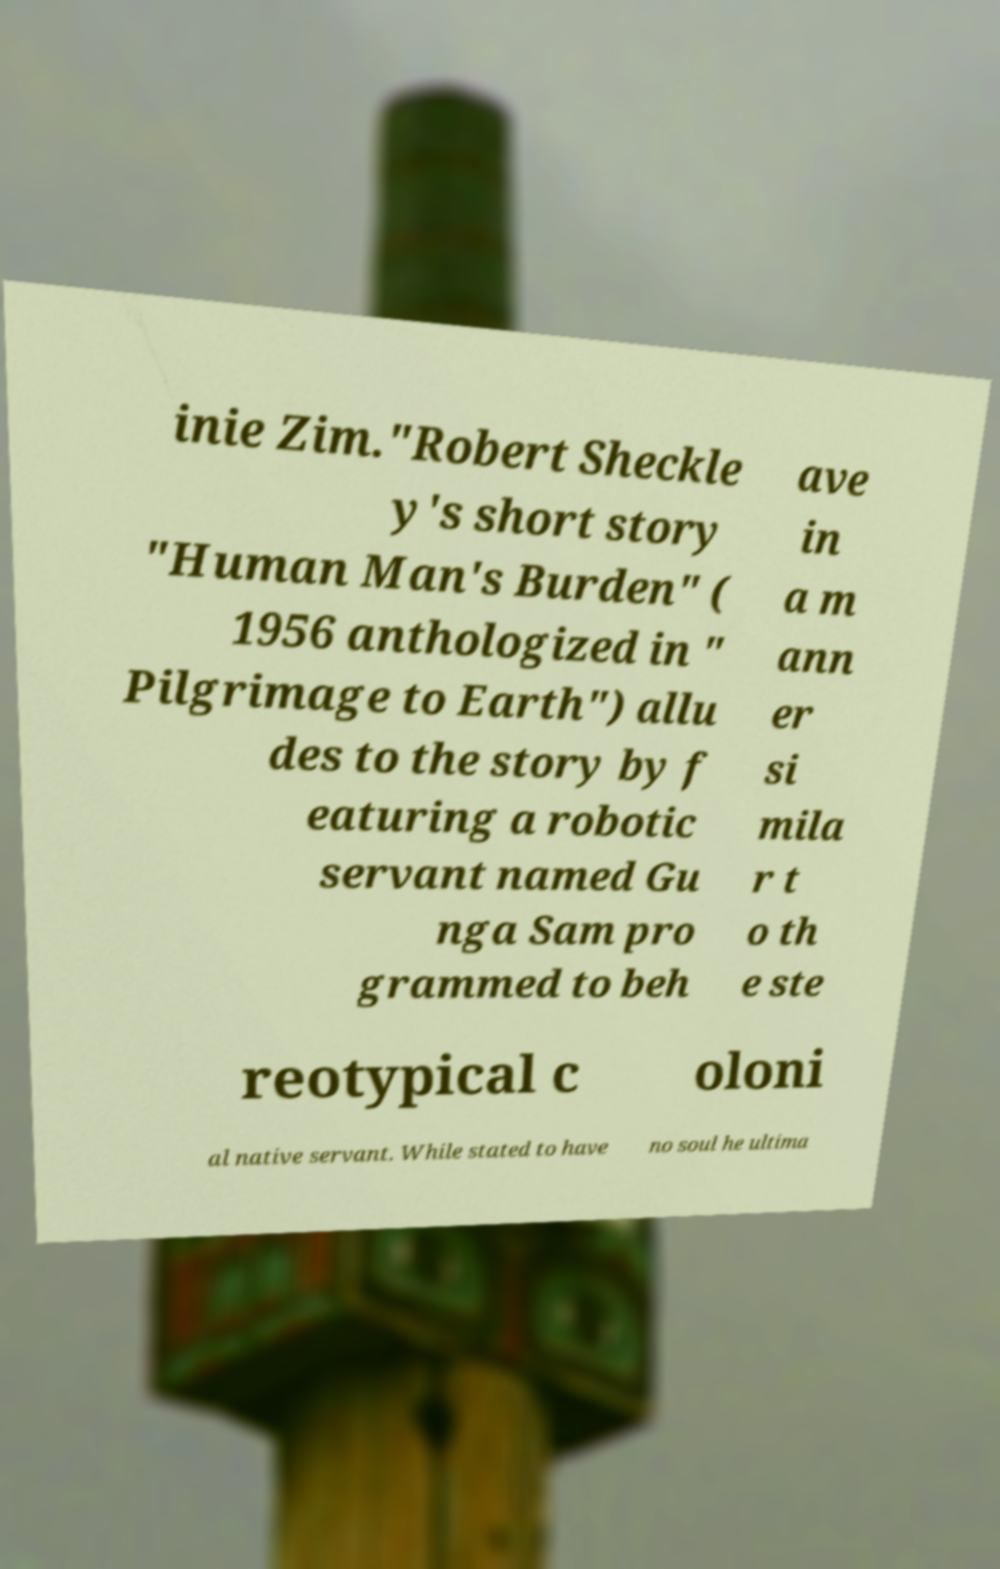There's text embedded in this image that I need extracted. Can you transcribe it verbatim? inie Zim."Robert Sheckle y's short story "Human Man's Burden" ( 1956 anthologized in " Pilgrimage to Earth") allu des to the story by f eaturing a robotic servant named Gu nga Sam pro grammed to beh ave in a m ann er si mila r t o th e ste reotypical c oloni al native servant. While stated to have no soul he ultima 